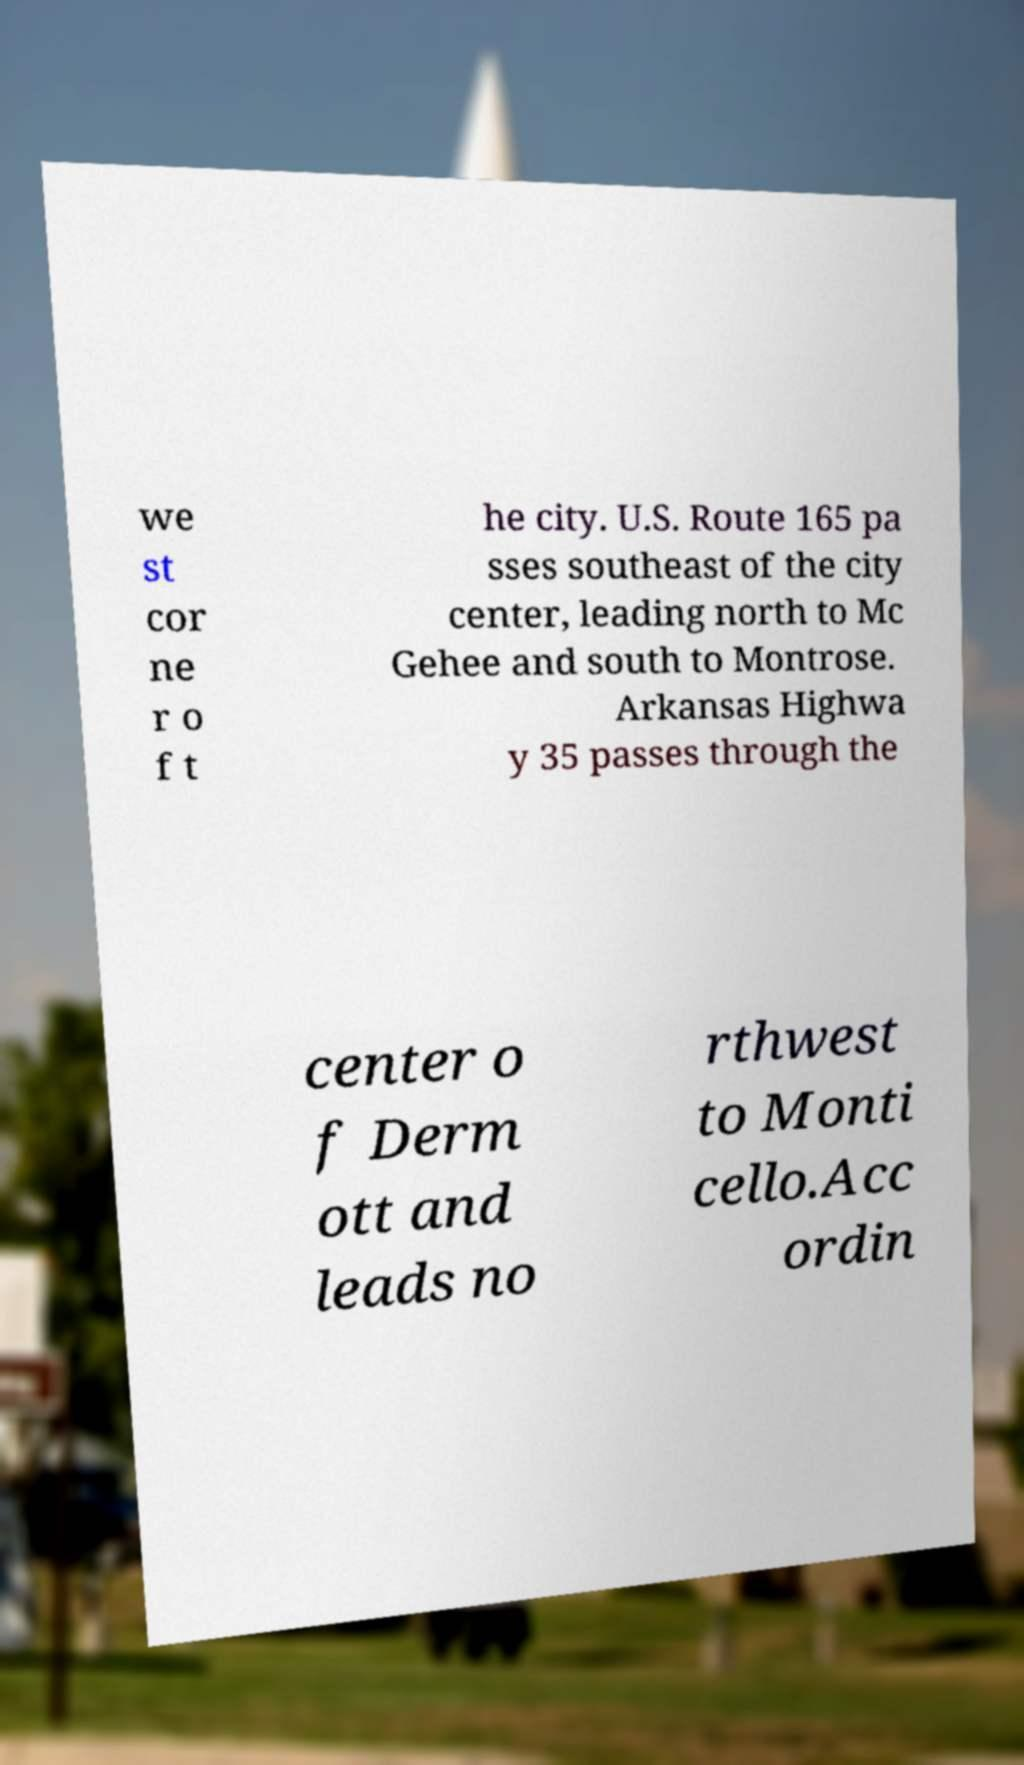For documentation purposes, I need the text within this image transcribed. Could you provide that? we st cor ne r o f t he city. U.S. Route 165 pa sses southeast of the city center, leading north to Mc Gehee and south to Montrose. Arkansas Highwa y 35 passes through the center o f Derm ott and leads no rthwest to Monti cello.Acc ordin 